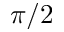<formula> <loc_0><loc_0><loc_500><loc_500>\pi / 2</formula> 